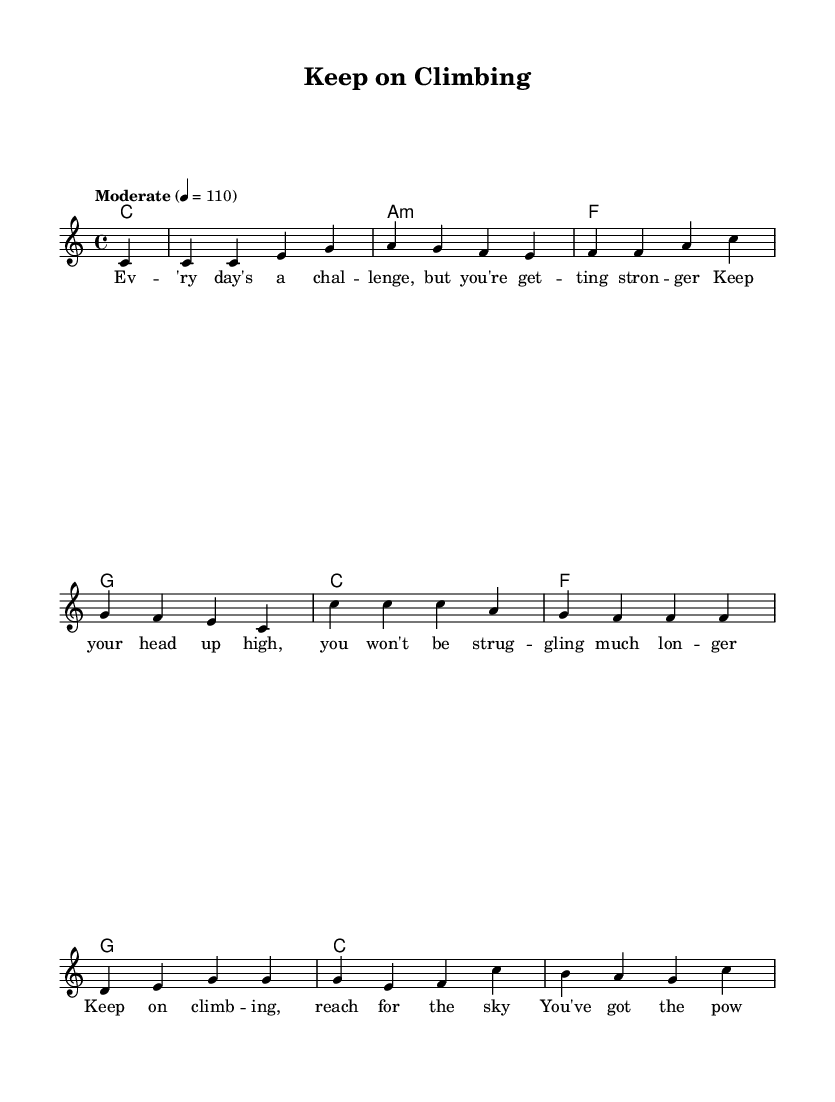What is the key signature of this music? The key signature is based on the initial indication in the global section, which shows "c \major," meaning there are no sharps or flats in this key.
Answer: C major What is the time signature of this music? The time signature is indicated in the global section and reads "4/4," which means there are four beats per measure.
Answer: 4/4 What is the tempo marking of this piece? The tempo is indicated in the global section as "Moderate" with a specific beats per minute marking of "4 = 110," meaning each quarter note should be played at a speed of 110 beats per minute.
Answer: Moderate, 110 How many measures are in the melody? To find this, we count the number of bars in the melody section starting from the first bar until the last one, which adds up to 8 measures in total.
Answer: 8 What is the main theme conveyed in the lyrics? The lyrics emphasize resilience and motivation in the face of challenges, captured by phrases that encourage perseverance and strength.
Answer: Perseverance Which chord follows the melody in the first measure? The harmony is identified in the chord mode section right below the melody, indicating that the first chord is "c," which corresponds with the melody that starts on a "c."
Answer: c How does the chorus lyrically support the overall message of the piece? The chorus lyrics are explicit in motivating the listener to strive upward, using strong action-oriented phrases like "Keep on climbing" and "reach for the sky," reinforcing the uplifting theme throughout the song.
Answer: Uplifting 